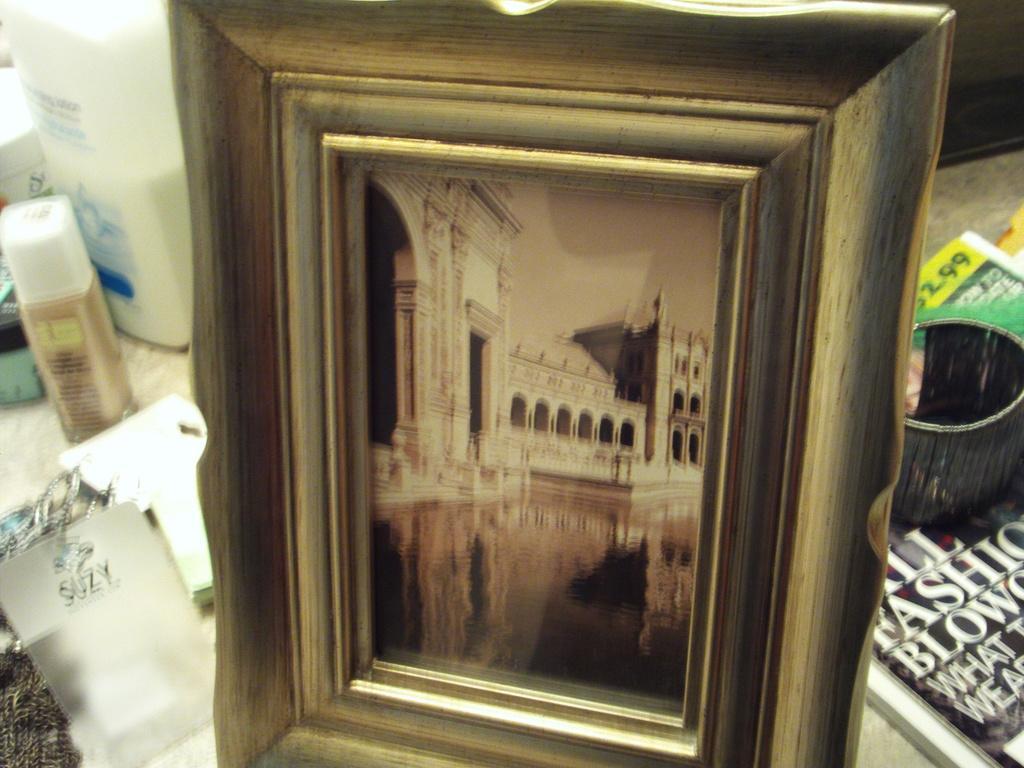How would you summarize this image in a sentence or two? In this image I can see a frame. Inside the frame I can see a building and water. I can see books,few objects on the surface. 